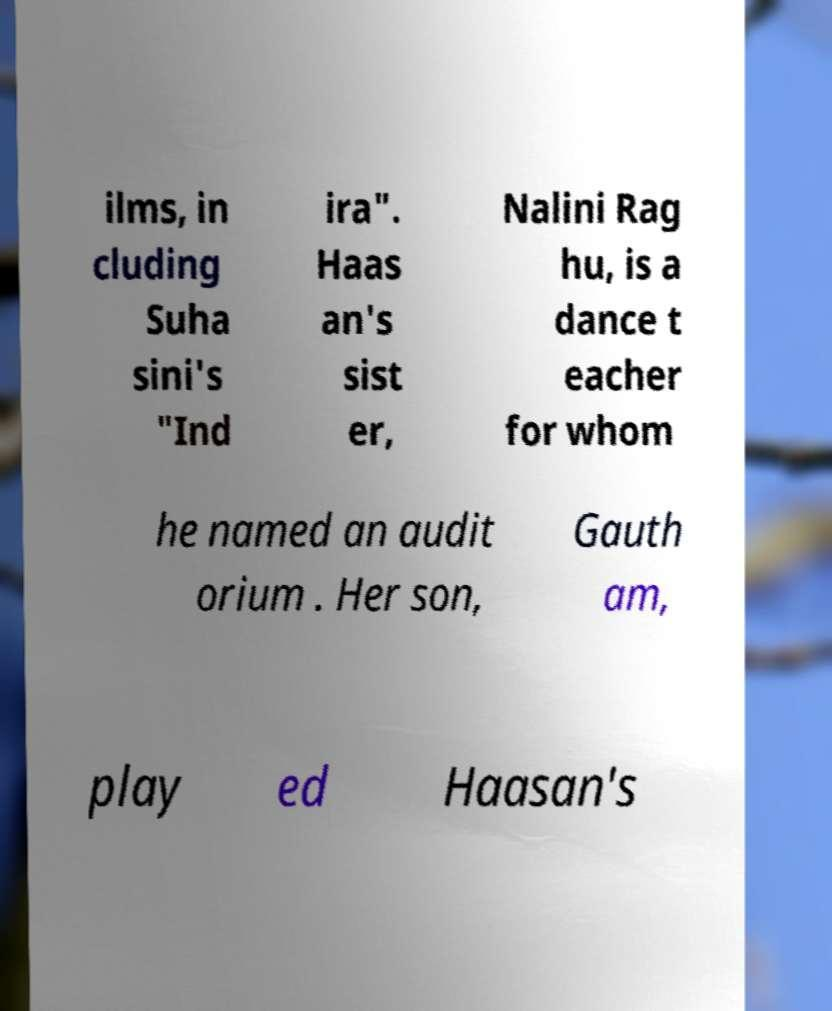Could you extract and type out the text from this image? ilms, in cluding Suha sini's "Ind ira". Haas an's sist er, Nalini Rag hu, is a dance t eacher for whom he named an audit orium . Her son, Gauth am, play ed Haasan's 